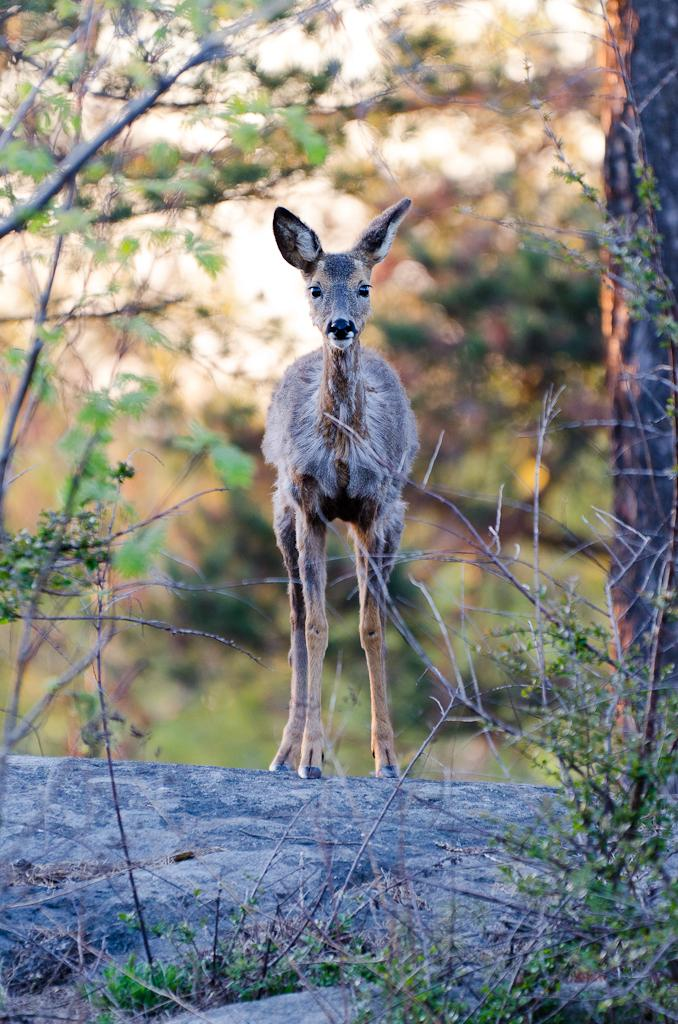What is the overall appearance of the background in the image? The background of the image is blurred. What can be seen in the foreground of the image? There is an animal standing in the image. What type of vegetation is visible in the image? There are branches and green leaves present in the image. Where is the tree trunk located in the image? The tree trunk is on the right side of the image. What type of cloud can be seen in the image? There is no cloud present in the image; the background is blurred, and the focus is on the animal and vegetation. 